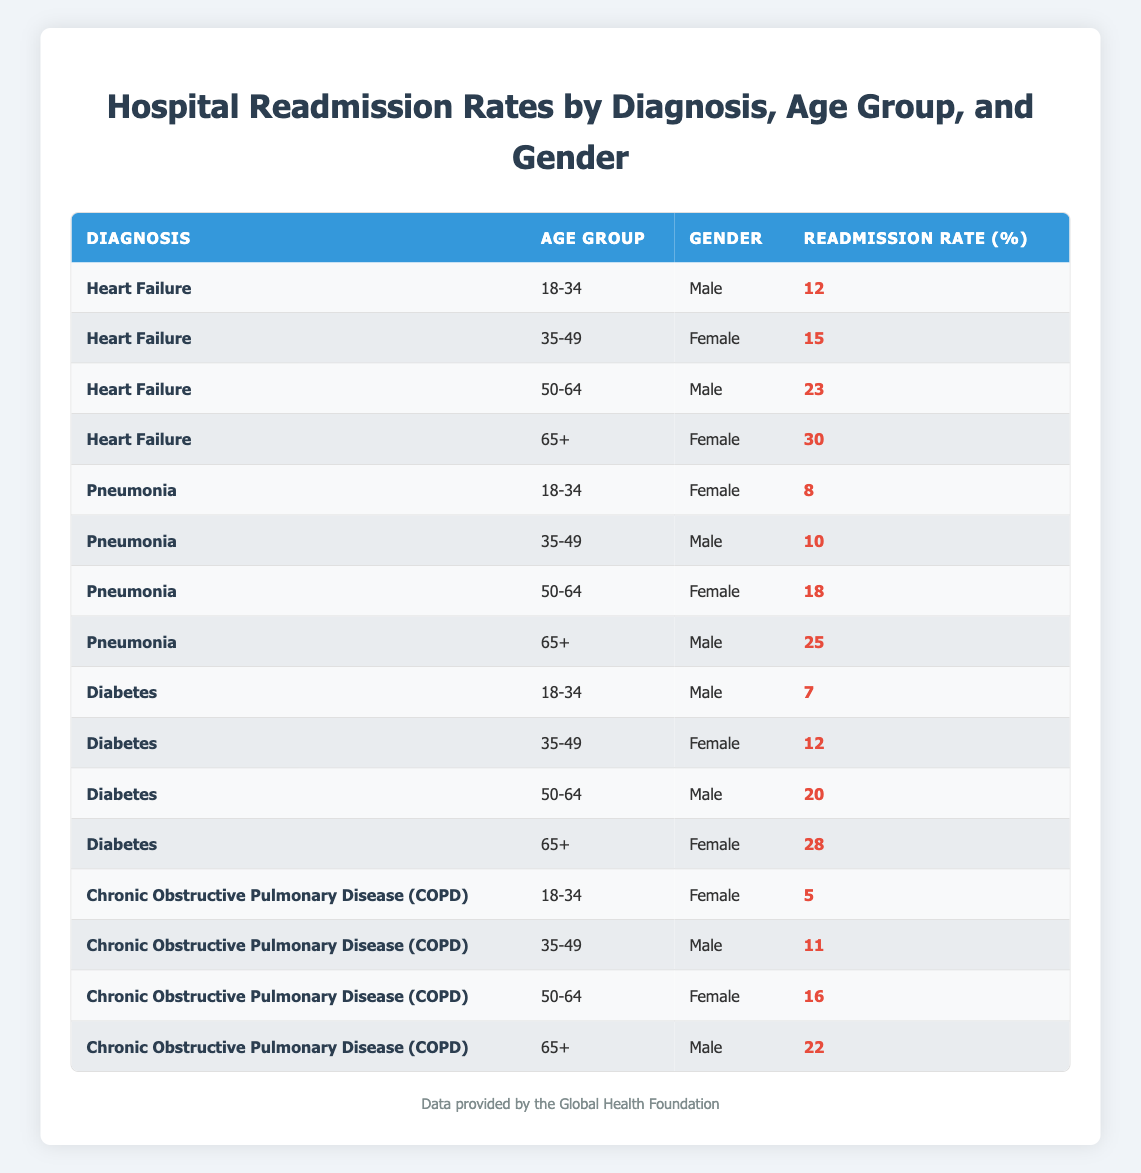What is the readmission rate for males aged 50-64 with heart failure? The table shows that for the diagnosis of heart failure, in the age group 50-64, the readmission rate for males is 23%.
Answer: 23% Which diagnosis has the highest readmission rate for females aged 65 and older? According to the table, females aged 65+ have the highest readmission rate under heart failure, which is 30%.
Answer: Heart Failure What is the average readmission rate for males across all age groups? The average readmission rate for males is calculated as follows: (12 + 23 + 10 + 20 + 11 + 22) / 6 = 108 / 6 = 18%.
Answer: 18% Is the readmission rate for pneumonia higher than 15% for any age group? Checking the readmission rates for pneumonia: 8%, 10%, 18%, and 25%. The rate for 50-64 is 18% and for 65+ is 25%, both higher than 15%.
Answer: Yes Which age group and gender combination has the lowest readmission rate? The table indicates that the combination with the lowest readmission rate is females aged 18-34 with chronic obstructive pulmonary disease, with a rate of 5%.
Answer: Females aged 18-34 with COPD What is the readmission rate difference between females aged 65+ with diabetes and males aged 65+ with COPD? From the table, the readmission rate for females aged 65+ with diabetes is 28% and for males aged 65+ with COPD is 22%. The difference is 28% - 22% = 6%.
Answer: 6% Do males have higher readmission rates than females for every diagnosis in the 50-64 age group? Looking at the table: For heart failure (23% female), pneumonia (18% female), diabetes (20% female), and COPD (16% female), males have higher rates only for heart failure. So the answer is no.
Answer: No What is the cumulative readmission rate for females aged 50-64 across all diagnoses? The rates for females aged 50-64 across all diagnoses are: heart failure (23%), pneumonia (18%), diabetes (28%), and COPD (16%). The cumulative rate is 23 + 18 + 28 + 16 = 85%.
Answer: 85% What is the readmission rate for diabetes among males aged 35-49? The table shows that the readmission rate for diabetes in males aged 35-49 is 12%.
Answer: 12% What percentage of the highest readmission rate for females aged 65+ (heart failure) exceeds the lowest readmission rate for males aged 18-34 (chronic obstructive pulmonary disease)? Females aged 65+ with heart failure have a readmission rate of 30%, while males aged 18-34 with COPD have a rate of 5%. The difference is 30% - 5% = 25%.
Answer: 25% 